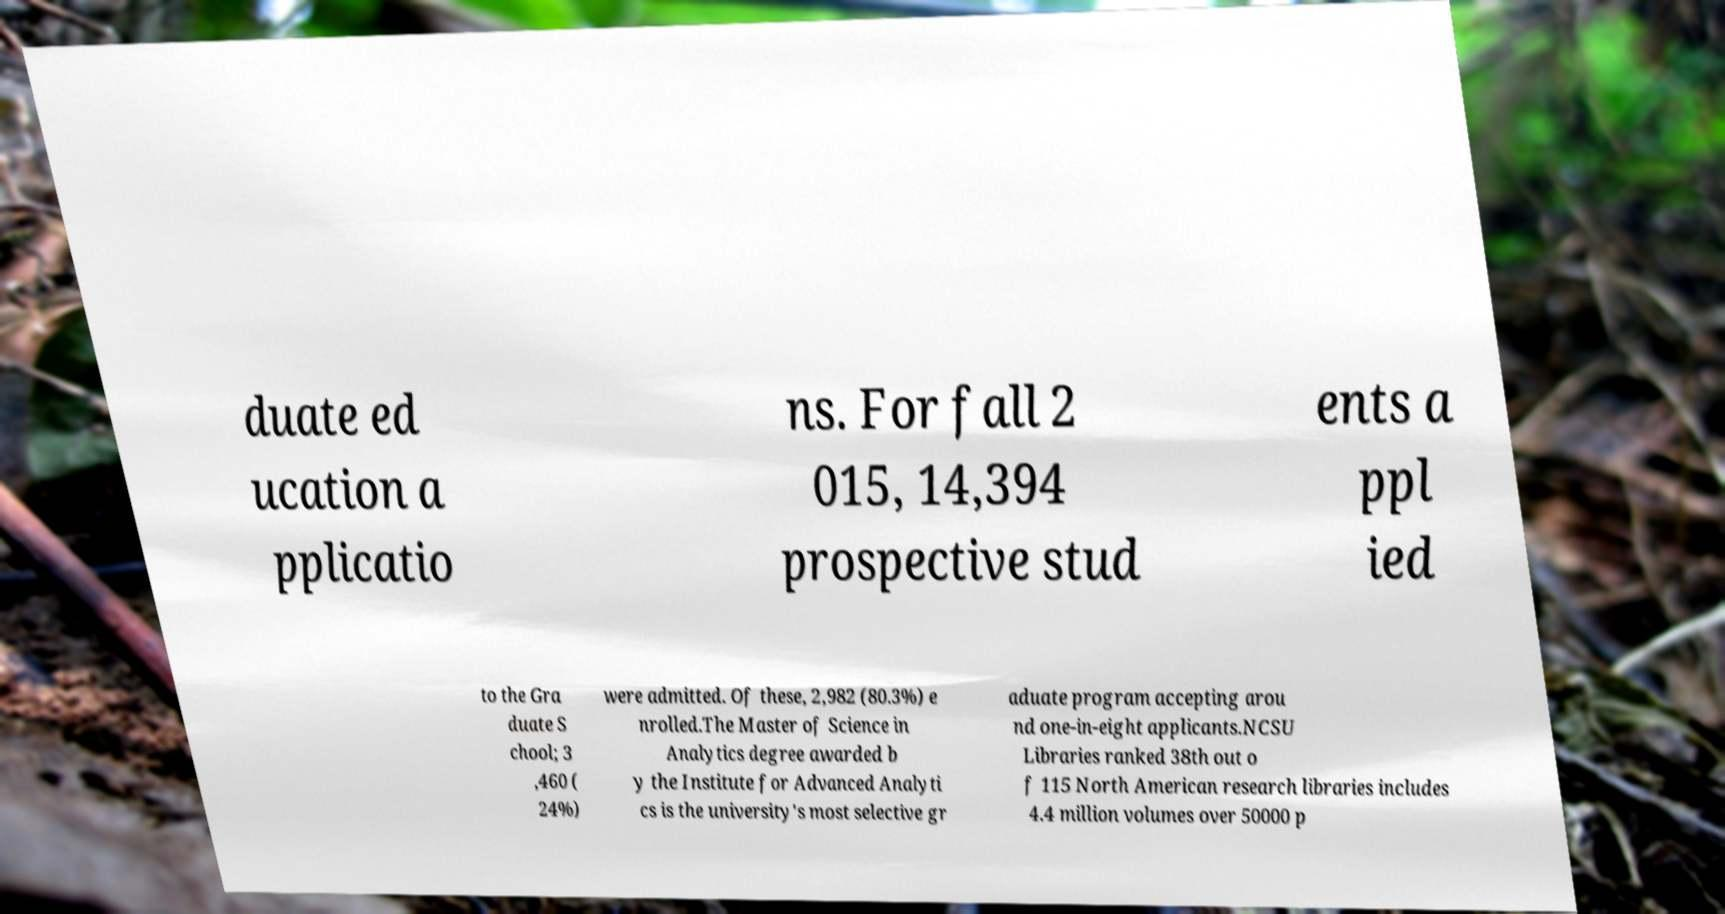Please read and relay the text visible in this image. What does it say? duate ed ucation a pplicatio ns. For fall 2 015, 14,394 prospective stud ents a ppl ied to the Gra duate S chool; 3 ,460 ( 24%) were admitted. Of these, 2,982 (80.3%) e nrolled.The Master of Science in Analytics degree awarded b y the Institute for Advanced Analyti cs is the university's most selective gr aduate program accepting arou nd one-in-eight applicants.NCSU Libraries ranked 38th out o f 115 North American research libraries includes 4.4 million volumes over 50000 p 